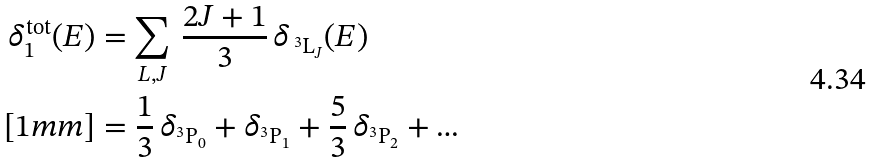<formula> <loc_0><loc_0><loc_500><loc_500>\delta ^ { \text {tot} } _ { 1 } ( E ) & = \sum _ { L , J } \, \frac { 2 J + 1 } { 3 } \, \delta _ { \, ^ { 3 } \text {L} _ { J } } ( E ) \\ [ 1 m m ] & = \frac { 1 } { 3 } \, \delta _ { ^ { 3 } \text {P} _ { 0 } } + \delta _ { ^ { 3 } \text {P} _ { 1 } } + \frac { 5 } { 3 } \, \delta _ { ^ { 3 } \text {P} _ { 2 } } + \dots</formula> 